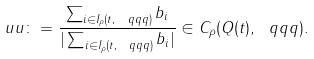<formula> <loc_0><loc_0><loc_500><loc_500>\ u u \colon = \frac { \sum _ { i \in I _ { \rho } ( t , \ q q q ) } b _ { i } } { | \sum _ { i \in I _ { \rho } ( t , \ q q q ) } b _ { i } | } \in C _ { \rho } ( Q ( t ) , \ q q q ) .</formula> 